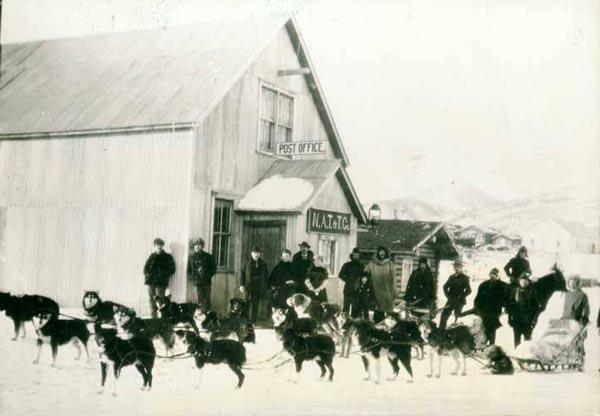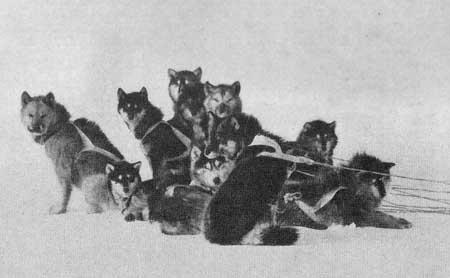The first image is the image on the left, the second image is the image on the right. Examine the images to the left and right. Is the description "A pack of dogs is standing in the snow near a building in the image on the left." accurate? Answer yes or no. Yes. The first image is the image on the left, the second image is the image on the right. Examine the images to the left and right. Is the description "One image shows a team of rope-hitched dogs resting on the snow, with no sled or any landmarks in sight and with at least some dogs reclining." accurate? Answer yes or no. Yes. 